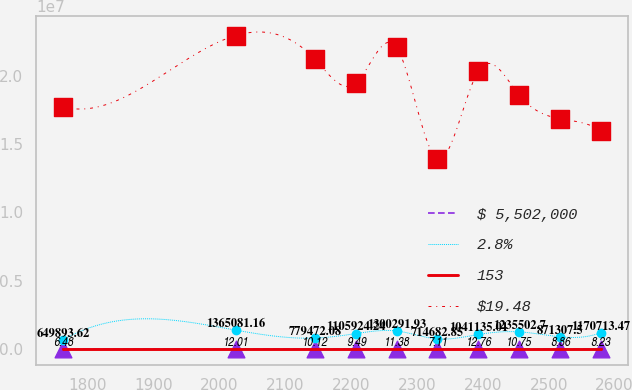Convert chart. <chart><loc_0><loc_0><loc_500><loc_500><line_chart><ecel><fcel>$ 5,502,000<fcel>2.8%<fcel>153<fcel>$19.48<nl><fcel>1762.5<fcel>201.27<fcel>649894<fcel>6.48<fcel>1.77526e+07<nl><fcel>2024.34<fcel>174.14<fcel>1.36508e+06<fcel>12.01<fcel>2.29823e+07<nl><fcel>2145.16<fcel>147<fcel>779472<fcel>10.12<fcel>2.12391e+07<nl><fcel>2207.13<fcel>133.43<fcel>1.10592e+06<fcel>9.49<fcel>1.94958e+07<nl><fcel>2269.1<fcel>160.57<fcel>1.30029e+06<fcel>11.38<fcel>2.21107e+07<nl><fcel>2331.07<fcel>79.15<fcel>714683<fcel>7.11<fcel>1.3929e+07<nl><fcel>2393.04<fcel>119.86<fcel>1.04114e+06<fcel>12.76<fcel>2.03675e+07<nl><fcel>2455.01<fcel>65.58<fcel>1.2355e+06<fcel>10.75<fcel>1.86242e+07<nl><fcel>2516.98<fcel>92.72<fcel>871308<fcel>8.86<fcel>1.6881e+07<nl><fcel>2578.95<fcel>106.29<fcel>1.17071e+06<fcel>8.23<fcel>1.60093e+07<nl></chart> 